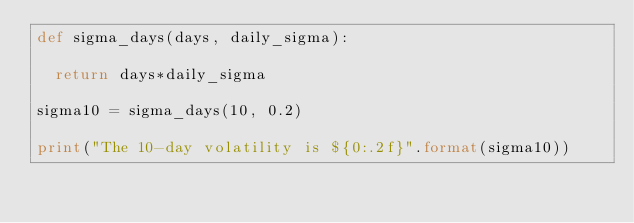<code> <loc_0><loc_0><loc_500><loc_500><_Python_>def sigma_days(days, daily_sigma):
	
	return days*daily_sigma

sigma10 = sigma_days(10, 0.2)

print("The 10-day volatility is ${0:.2f}".format(sigma10))
</code> 